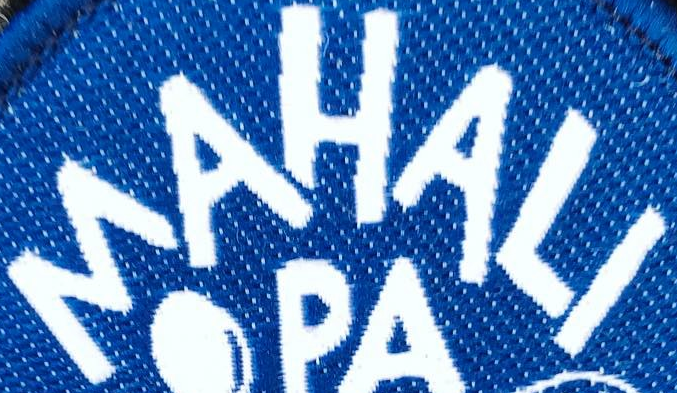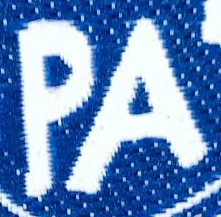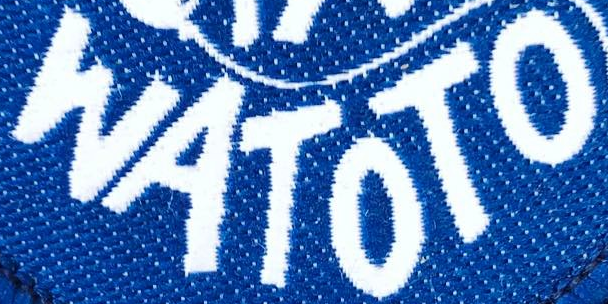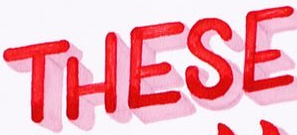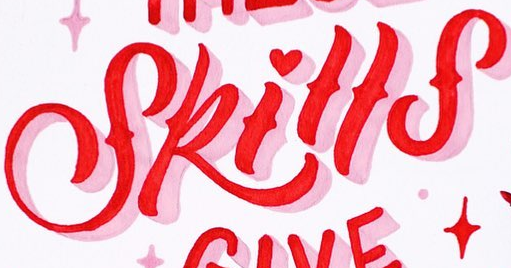Read the text from these images in sequence, separated by a semicolon. MAHALI; PA; WATOTO; THESE; Skills 